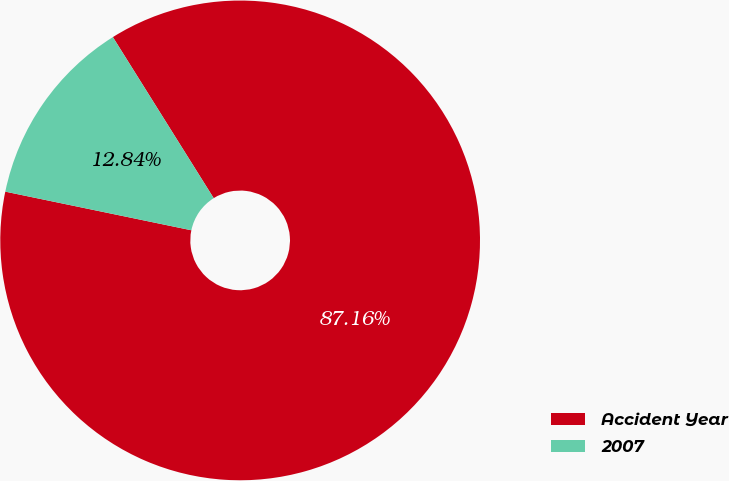Convert chart to OTSL. <chart><loc_0><loc_0><loc_500><loc_500><pie_chart><fcel>Accident Year<fcel>2007<nl><fcel>87.16%<fcel>12.84%<nl></chart> 